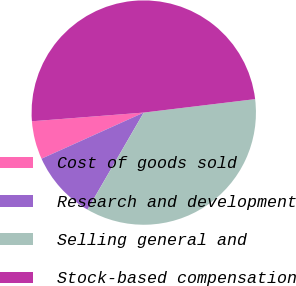<chart> <loc_0><loc_0><loc_500><loc_500><pie_chart><fcel>Cost of goods sold<fcel>Research and development<fcel>Selling general and<fcel>Stock-based compensation<nl><fcel>5.51%<fcel>9.89%<fcel>35.28%<fcel>49.33%<nl></chart> 